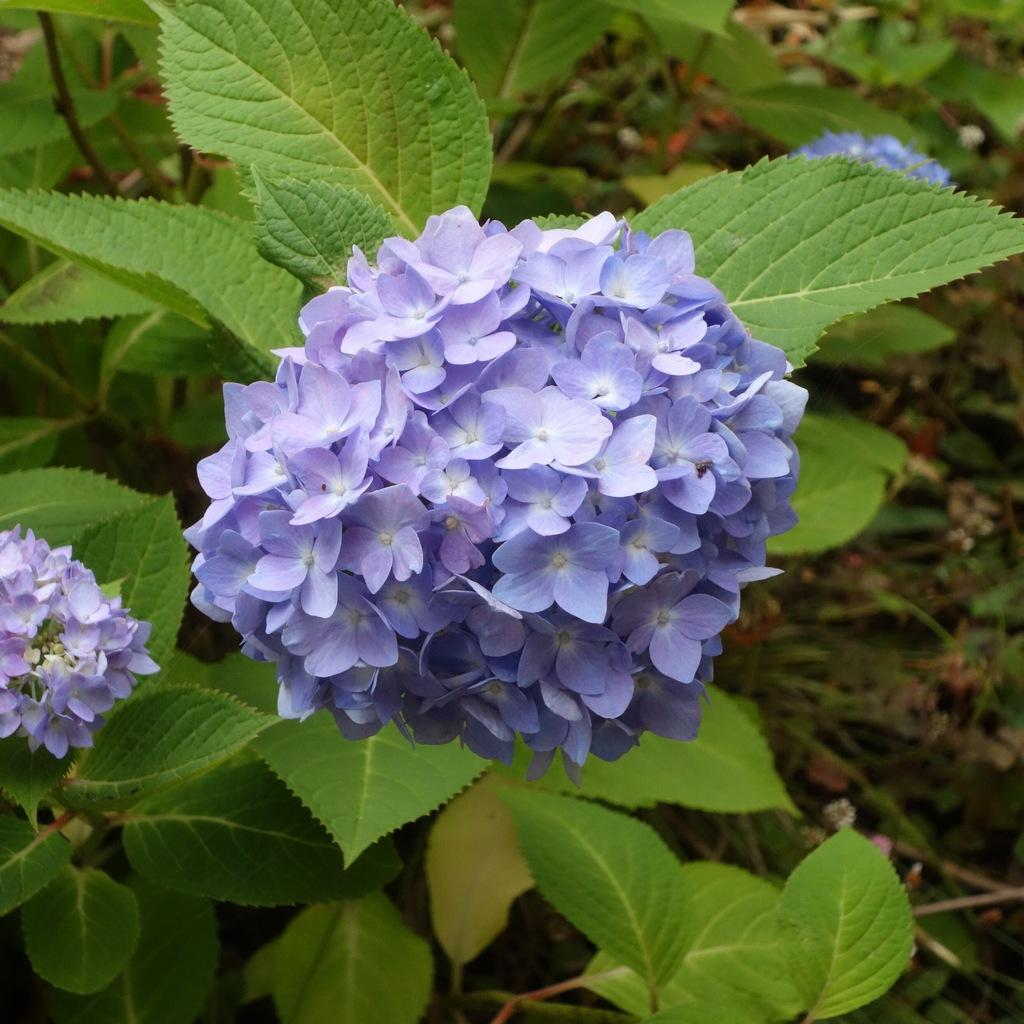What type of plant life is featured in the image? There are bunches of flowers in the image. What can be seen in the background of the image? Leaves and stems are visible in the background of the image. What type of poison is present in the image? A: There is no poison present in the image; it features bunches of flowers, leaves, and stems. What fact can be determined about the image based on the presence of the flowers? The fact that there are bunches of flowers in the image suggests that it may be a garden or floral arrangement. 